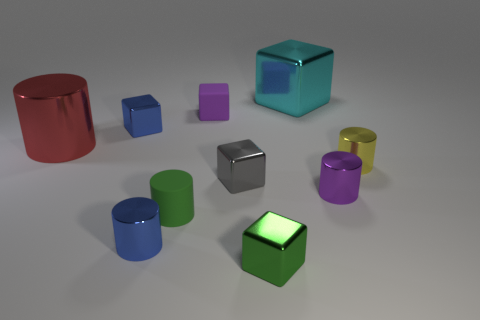There is a green object that is the same shape as the small gray metallic thing; what is it made of?
Make the answer very short. Metal. Do the purple thing that is in front of the big red metallic cylinder and the green object left of the gray shiny thing have the same shape?
Offer a terse response. Yes. Are there more brown shiny balls than green rubber cylinders?
Provide a succinct answer. No. How big is the gray metallic block?
Offer a terse response. Small. What number of other things are the same color as the large shiny cylinder?
Ensure brevity in your answer.  0. Is the green object that is in front of the green cylinder made of the same material as the cyan object?
Offer a terse response. Yes. Is the number of gray things in front of the small green matte thing less than the number of blue cylinders behind the red metallic object?
Offer a terse response. No. What number of other objects are there of the same material as the tiny blue cylinder?
Your answer should be very brief. 7. There is a red thing that is the same size as the cyan metal thing; what material is it?
Your answer should be compact. Metal. Are there fewer small metal objects that are left of the yellow cylinder than cyan metal cubes?
Make the answer very short. No. 